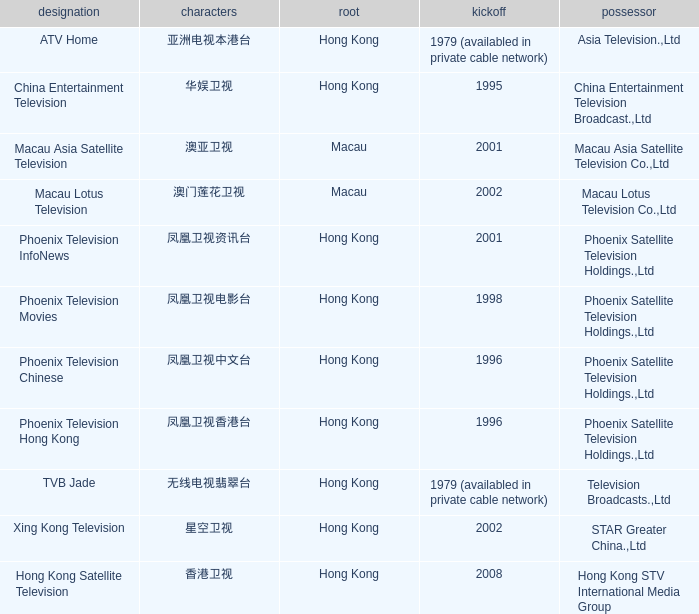Where did the Hanzi of 凤凰卫视电影台 originate? Hong Kong. 